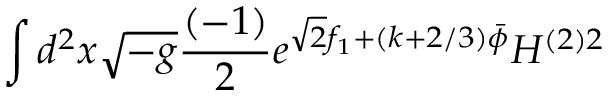Convert formula to latex. <formula><loc_0><loc_0><loc_500><loc_500>\int d ^ { 2 } x \sqrt { - g } \frac { ( - 1 ) } { 2 } e ^ { \sqrt { 2 } f _ { 1 } + ( k + 2 / 3 ) \bar { \phi } } H ^ { ( 2 ) 2 }</formula> 